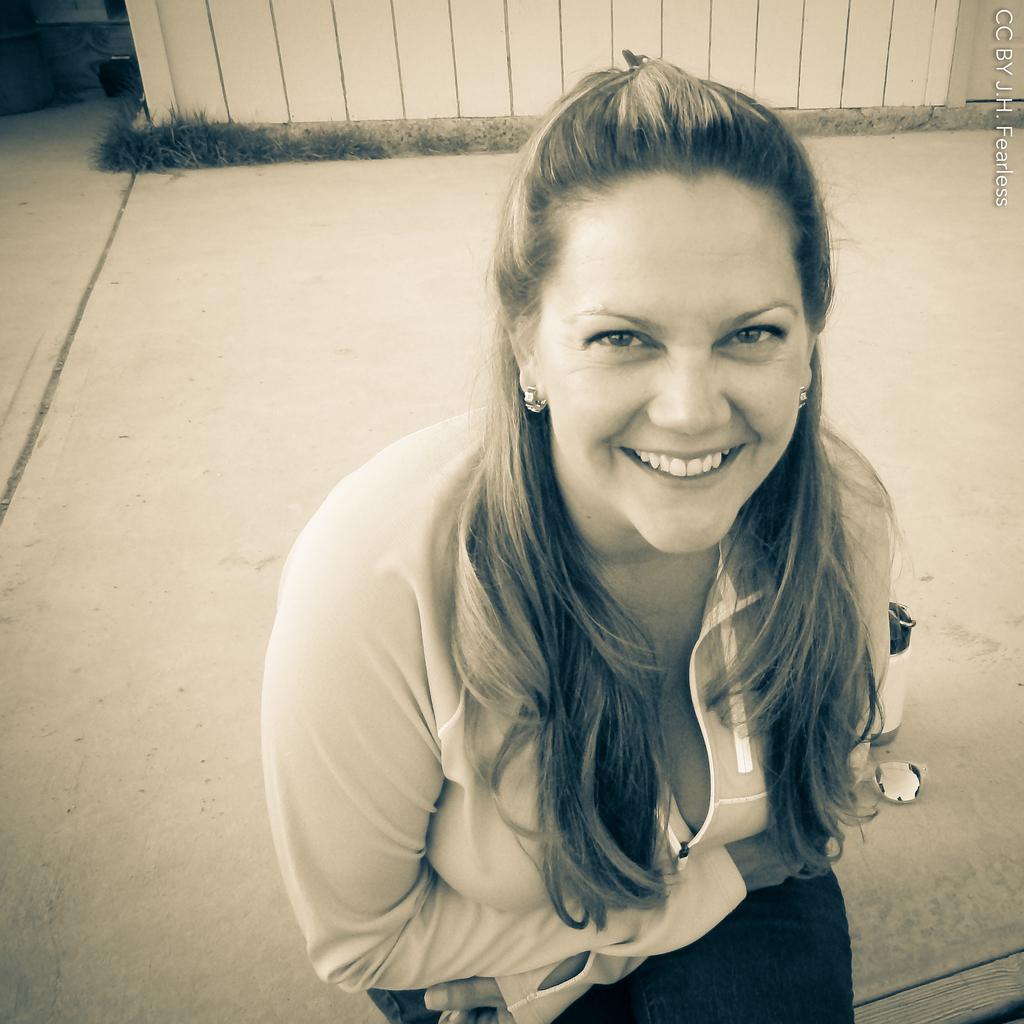How would you summarize this image in a sentence or two? In the image we can see a woman sitting, she is wearing clothes and earrings, and she is smiling. There is a bottle, footpath, watermark, grass and a fence. 